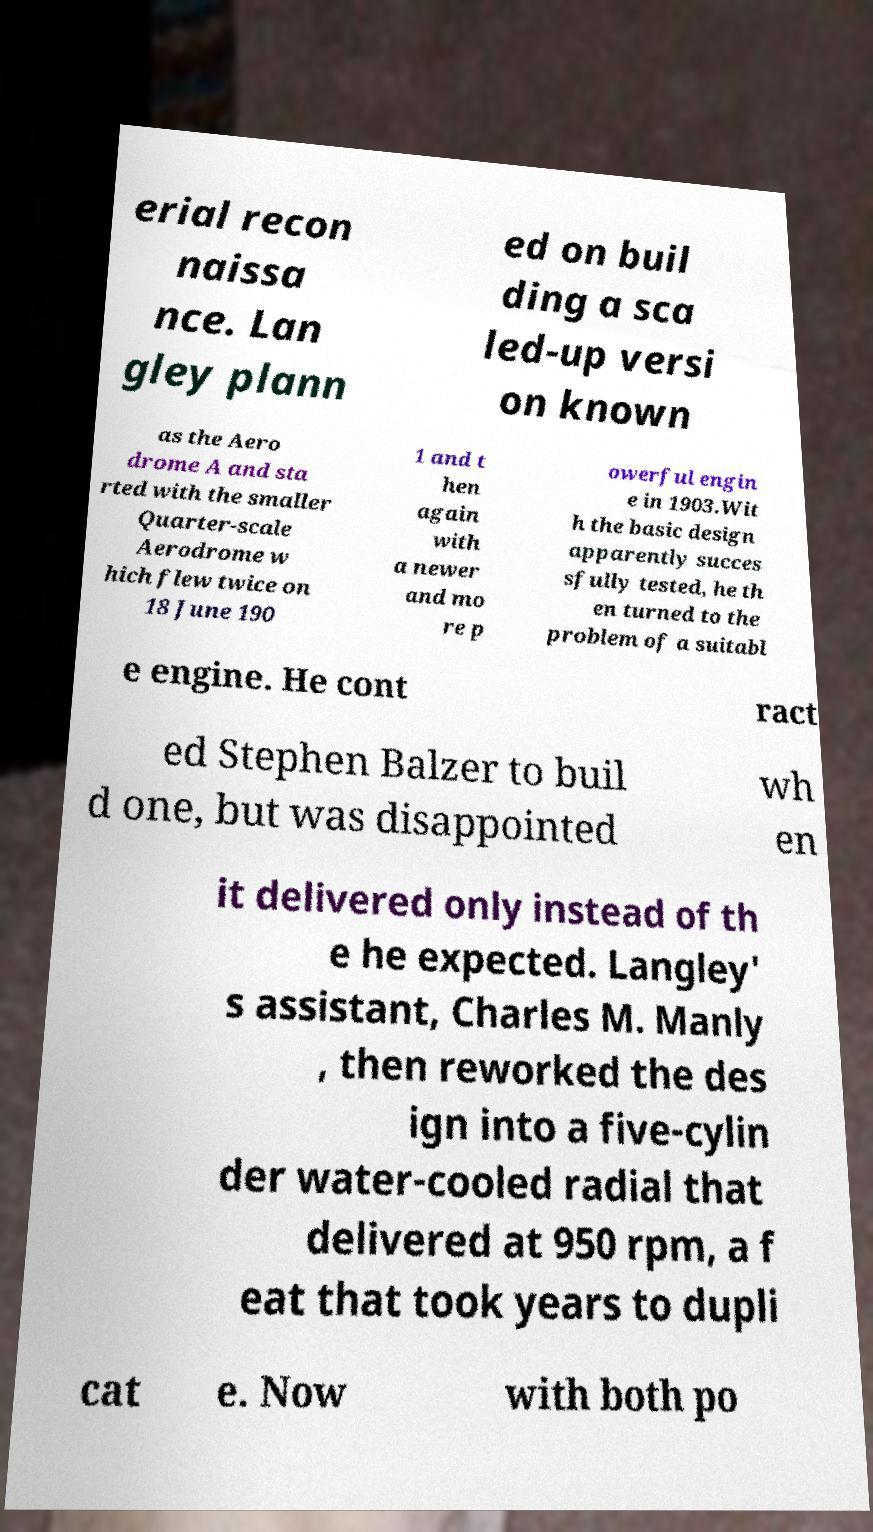What messages or text are displayed in this image? I need them in a readable, typed format. erial recon naissa nce. Lan gley plann ed on buil ding a sca led-up versi on known as the Aero drome A and sta rted with the smaller Quarter-scale Aerodrome w hich flew twice on 18 June 190 1 and t hen again with a newer and mo re p owerful engin e in 1903.Wit h the basic design apparently succes sfully tested, he th en turned to the problem of a suitabl e engine. He cont ract ed Stephen Balzer to buil d one, but was disappointed wh en it delivered only instead of th e he expected. Langley' s assistant, Charles M. Manly , then reworked the des ign into a five-cylin der water-cooled radial that delivered at 950 rpm, a f eat that took years to dupli cat e. Now with both po 